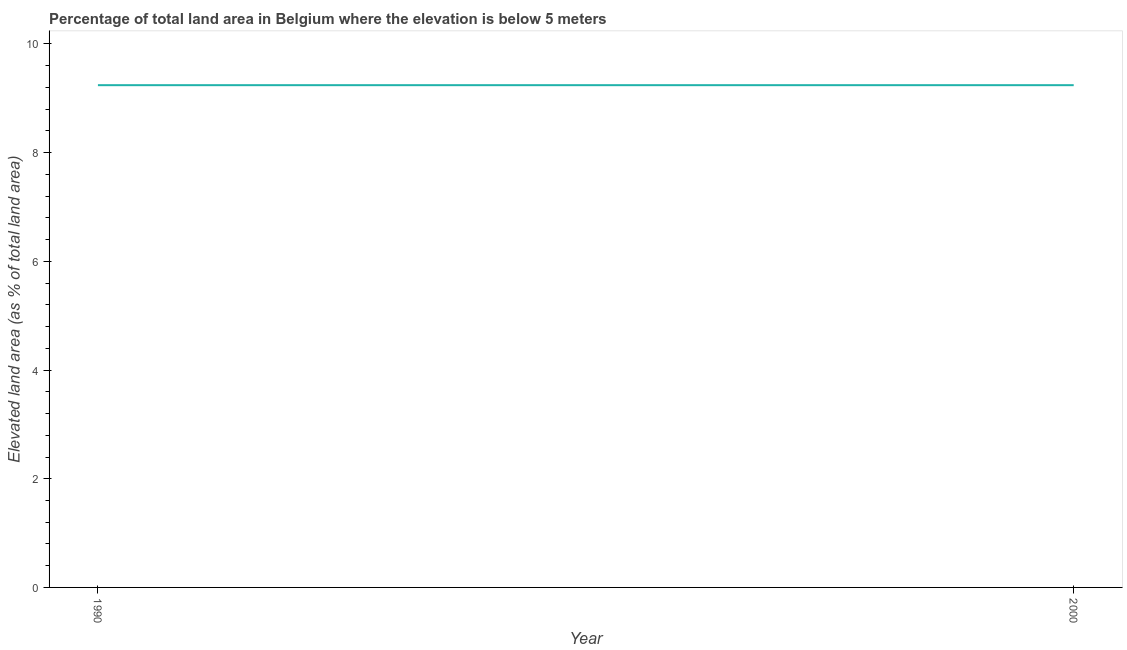What is the total elevated land area in 1990?
Provide a succinct answer. 9.24. Across all years, what is the maximum total elevated land area?
Ensure brevity in your answer.  9.24. Across all years, what is the minimum total elevated land area?
Provide a succinct answer. 9.24. In which year was the total elevated land area maximum?
Provide a succinct answer. 1990. What is the sum of the total elevated land area?
Ensure brevity in your answer.  18.48. What is the average total elevated land area per year?
Make the answer very short. 9.24. What is the median total elevated land area?
Ensure brevity in your answer.  9.24. In how many years, is the total elevated land area greater than 5.2 %?
Provide a succinct answer. 2. Do a majority of the years between 1990 and 2000 (inclusive) have total elevated land area greater than 3.6 %?
Your response must be concise. Yes. Does the total elevated land area monotonically increase over the years?
Your response must be concise. No. How many lines are there?
Provide a short and direct response. 1. Are the values on the major ticks of Y-axis written in scientific E-notation?
Give a very brief answer. No. Does the graph contain any zero values?
Offer a very short reply. No. What is the title of the graph?
Provide a succinct answer. Percentage of total land area in Belgium where the elevation is below 5 meters. What is the label or title of the X-axis?
Keep it short and to the point. Year. What is the label or title of the Y-axis?
Make the answer very short. Elevated land area (as % of total land area). What is the Elevated land area (as % of total land area) of 1990?
Ensure brevity in your answer.  9.24. What is the Elevated land area (as % of total land area) of 2000?
Your response must be concise. 9.24. What is the difference between the Elevated land area (as % of total land area) in 1990 and 2000?
Keep it short and to the point. 0. 